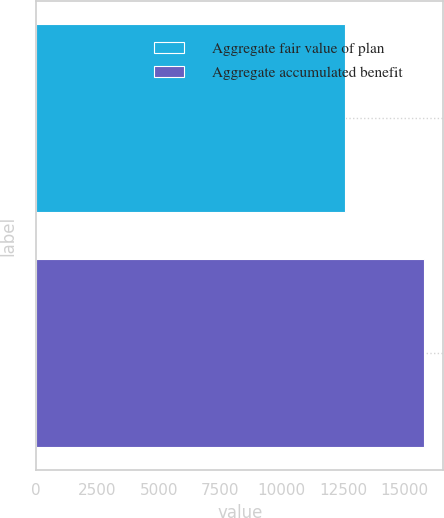Convert chart to OTSL. <chart><loc_0><loc_0><loc_500><loc_500><bar_chart><fcel>Aggregate fair value of plan<fcel>Aggregate accumulated benefit<nl><fcel>12578<fcel>15797<nl></chart> 